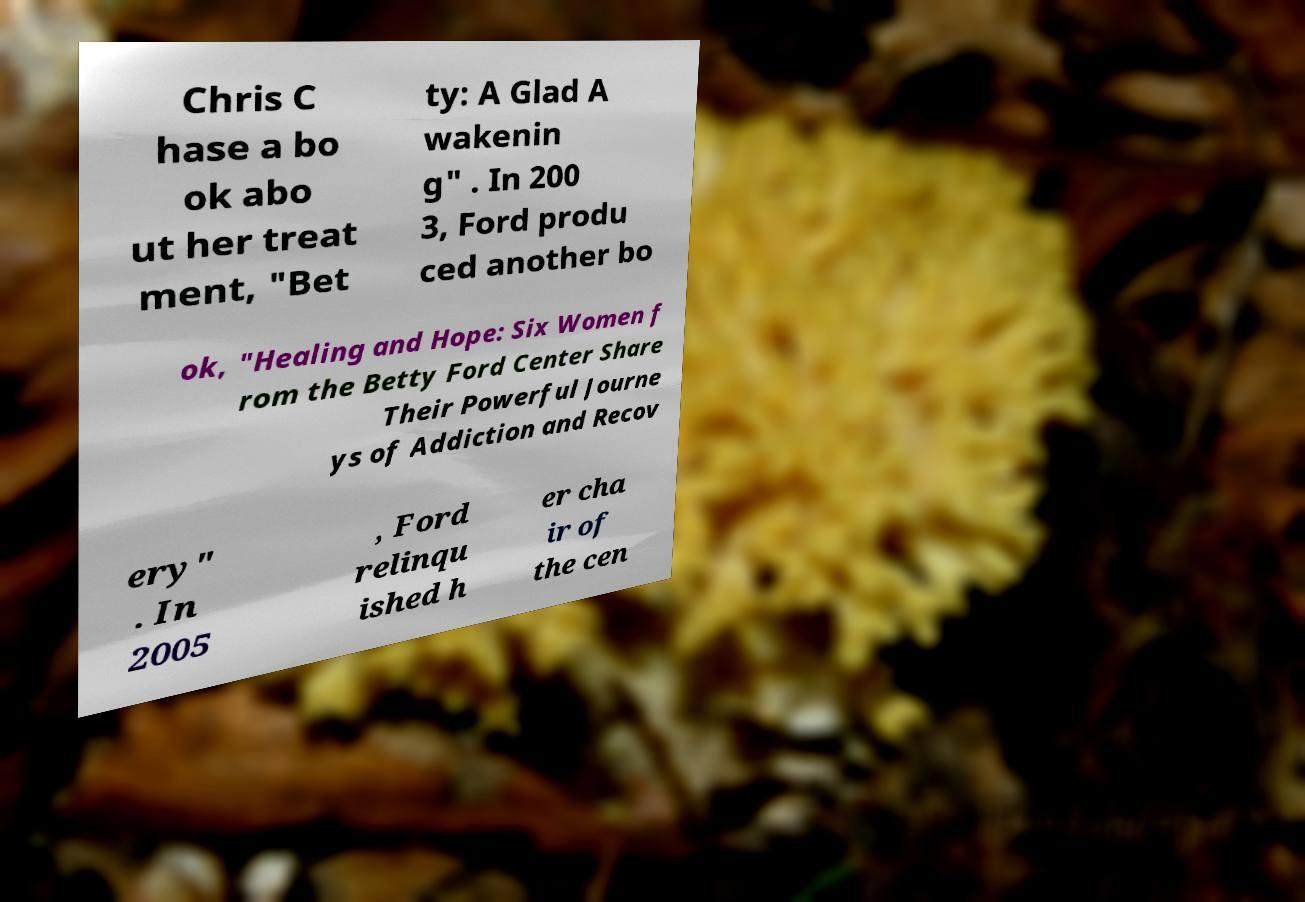For documentation purposes, I need the text within this image transcribed. Could you provide that? Chris C hase a bo ok abo ut her treat ment, "Bet ty: A Glad A wakenin g" . In 200 3, Ford produ ced another bo ok, "Healing and Hope: Six Women f rom the Betty Ford Center Share Their Powerful Journe ys of Addiction and Recov ery" . In 2005 , Ford relinqu ished h er cha ir of the cen 